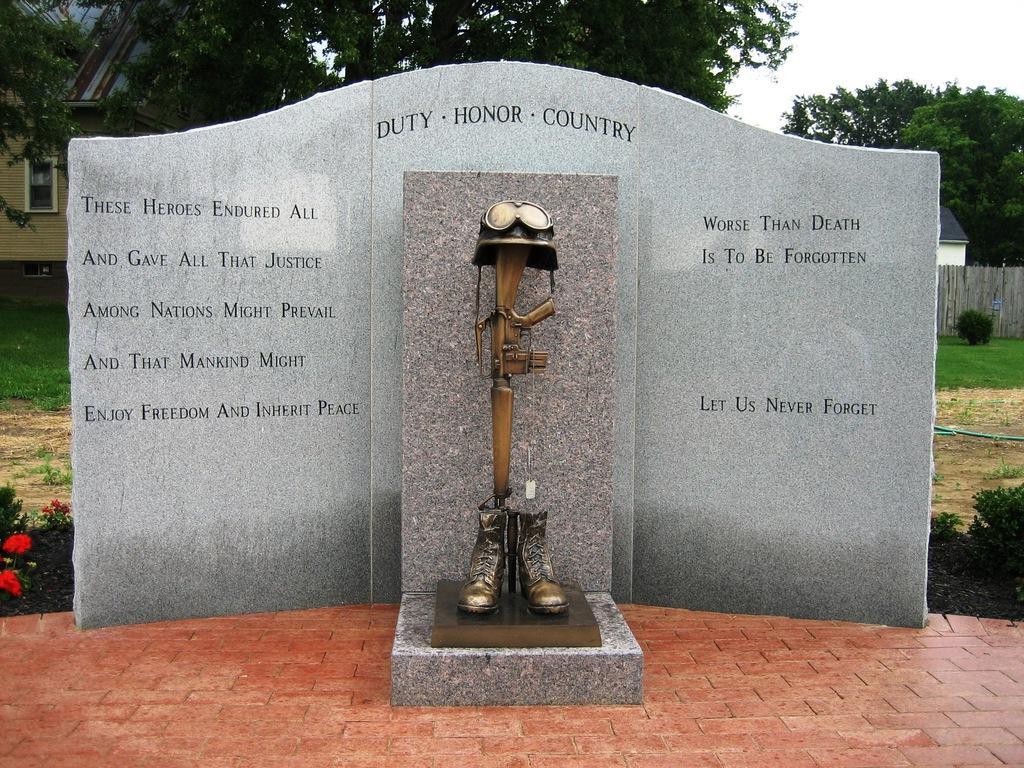Can you describe this image briefly? In this image we can see a wall with text on it and sculptures placed in front of the wall. In the background there are buildings, trees, ground, shrubs, flowers and sky. 